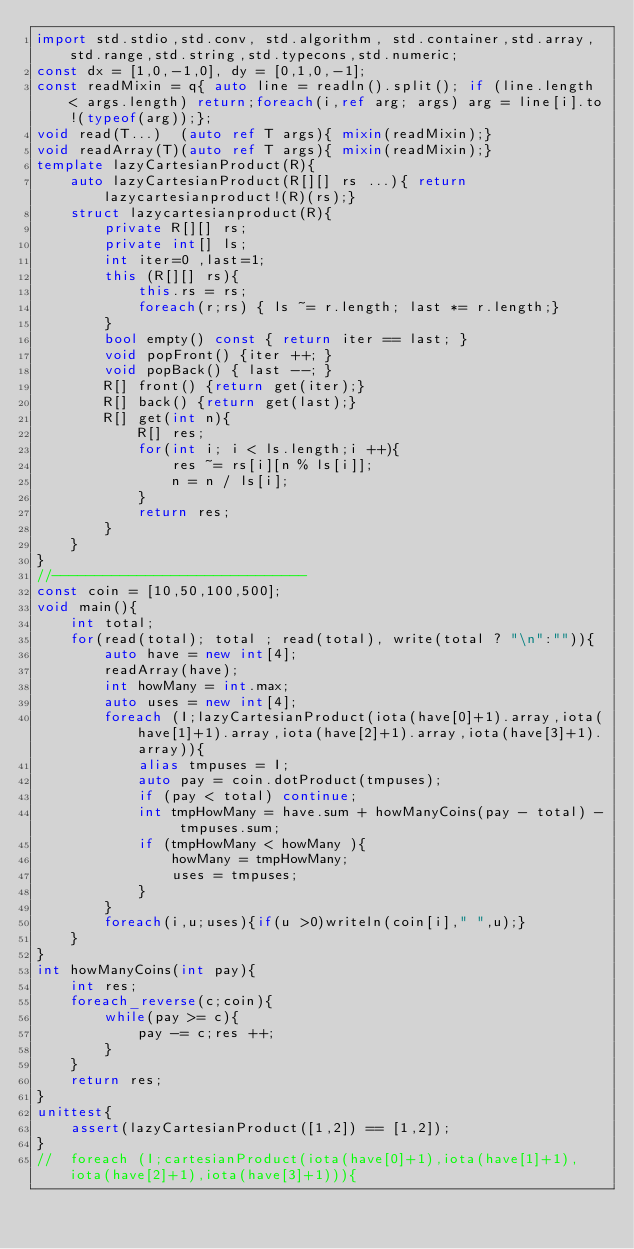<code> <loc_0><loc_0><loc_500><loc_500><_D_>import std.stdio,std.conv, std.algorithm, std.container,std.array,std.range,std.string,std.typecons,std.numeric;
const dx = [1,0,-1,0], dy = [0,1,0,-1];
const readMixin = q{ auto line = readln().split(); if (line.length < args.length) return;foreach(i,ref arg; args) arg = line[i].to!(typeof(arg));};
void read(T...)  (auto ref T args){ mixin(readMixin);}
void readArray(T)(auto ref T args){ mixin(readMixin);}
template lazyCartesianProduct(R){
	auto lazyCartesianProduct(R[][] rs ...){ return lazycartesianproduct!(R)(rs);}
	struct lazycartesianproduct(R){
		private R[][] rs; 
		private int[] ls;
		int iter=0 ,last=1;
		this (R[][] rs){
			this.rs = rs;
			foreach(r;rs) { ls ~= r.length; last *= r.length;}
		}
		bool empty() const { return iter == last; }
		void popFront() {iter ++; }
		void popBack() { last --; }
		R[] front() {return get(iter);}
		R[] back() {return get(last);}
		R[] get(int n){
			R[] res; 
			for(int i; i < ls.length;i ++){
				res ~= rs[i][n % ls[i]];
				n = n / ls[i];
			}
			return res;
		}
	}
}
//------------------------------
const coin = [10,50,100,500];
void main(){
	int total;
	for(read(total); total ; read(total), write(total ? "\n":"")){
		auto have = new int[4];
		readArray(have);
		int howMany = int.max; 
		auto uses = new int[4];
		foreach (I;lazyCartesianProduct(iota(have[0]+1).array,iota(have[1]+1).array,iota(have[2]+1).array,iota(have[3]+1).array)){
			alias tmpuses = I;
			auto pay = coin.dotProduct(tmpuses);	
			if (pay < total) continue;
			int tmpHowMany = have.sum + howManyCoins(pay - total) - tmpuses.sum;
			if (tmpHowMany < howMany ){
				howMany = tmpHowMany;
				uses = tmpuses;
			}
		}
		foreach(i,u;uses){if(u >0)writeln(coin[i]," ",u);}
	}
}
int howManyCoins(int pay){
	int res;
	foreach_reverse(c;coin){
		while(pay >= c){ 
			pay -= c;res ++;
		}
	} 
	return res;
}
unittest{
	assert(lazyCartesianProduct([1,2]) == [1,2]);
}
//	foreach (I;cartesianProduct(iota(have[0]+1),iota(have[1]+1),iota(have[2]+1),iota(have[3]+1))){</code> 